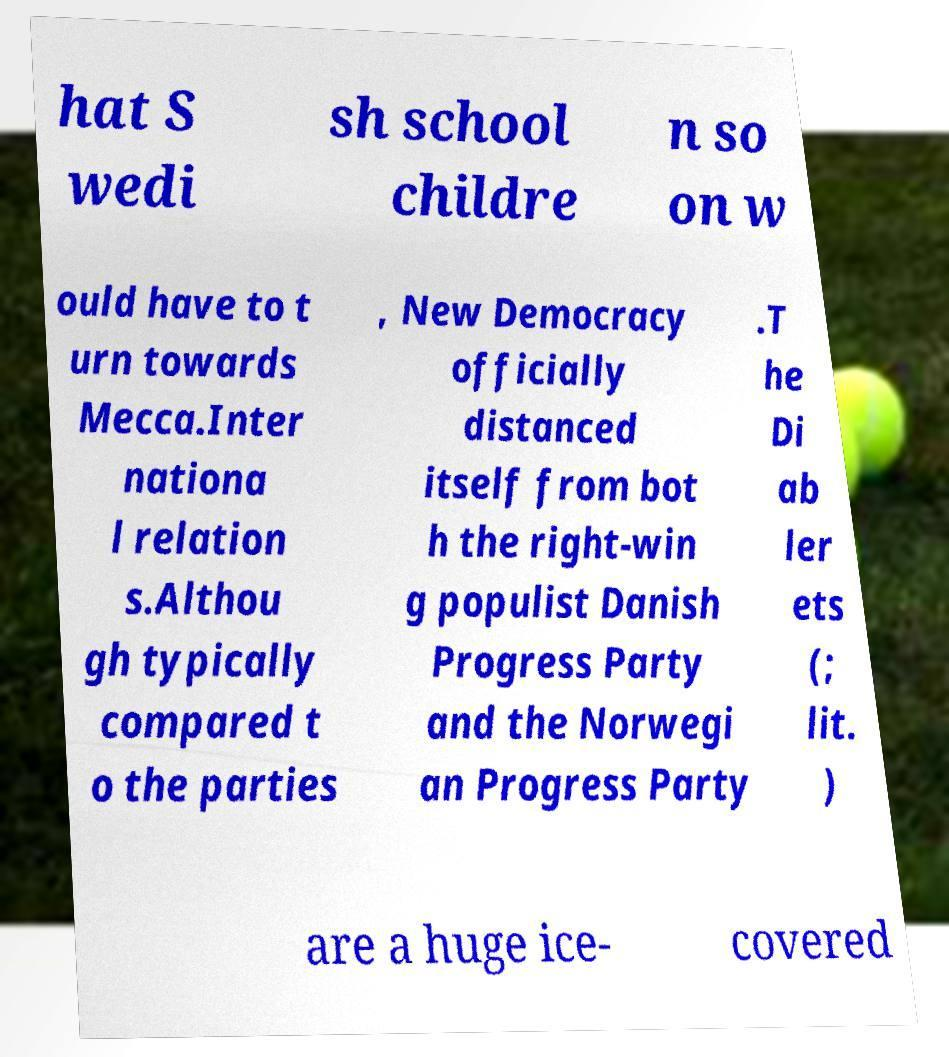Could you assist in decoding the text presented in this image and type it out clearly? hat S wedi sh school childre n so on w ould have to t urn towards Mecca.Inter nationa l relation s.Althou gh typically compared t o the parties , New Democracy officially distanced itself from bot h the right-win g populist Danish Progress Party and the Norwegi an Progress Party .T he Di ab ler ets (; lit. ) are a huge ice- covered 